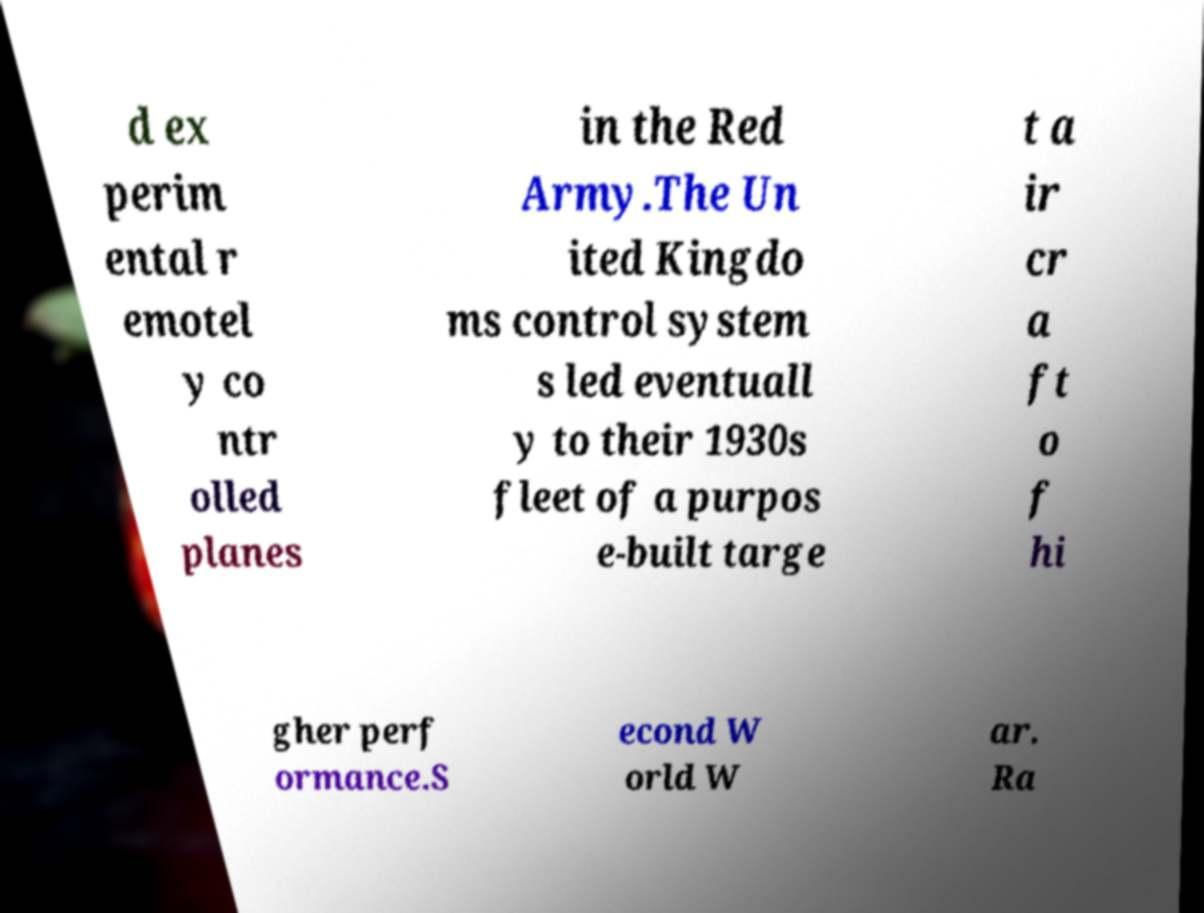I need the written content from this picture converted into text. Can you do that? d ex perim ental r emotel y co ntr olled planes in the Red Army.The Un ited Kingdo ms control system s led eventuall y to their 1930s fleet of a purpos e-built targe t a ir cr a ft o f hi gher perf ormance.S econd W orld W ar. Ra 